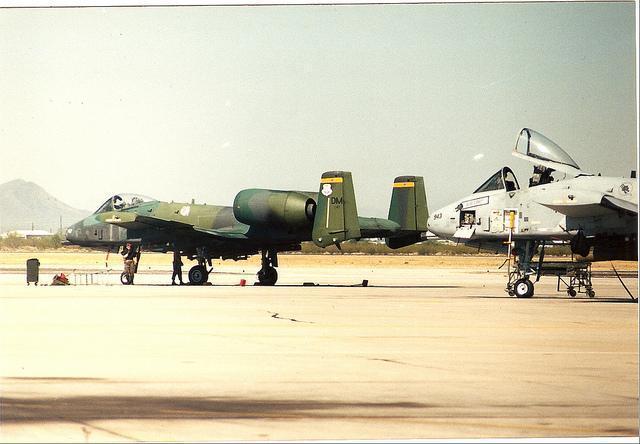How many engines does the first plane have?
Give a very brief answer. 2. How many airplanes are visible?
Give a very brief answer. 2. 